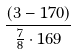Convert formula to latex. <formula><loc_0><loc_0><loc_500><loc_500>\frac { ( 3 - 1 7 0 ) } { \frac { 7 } { 8 } \cdot 1 6 9 }</formula> 